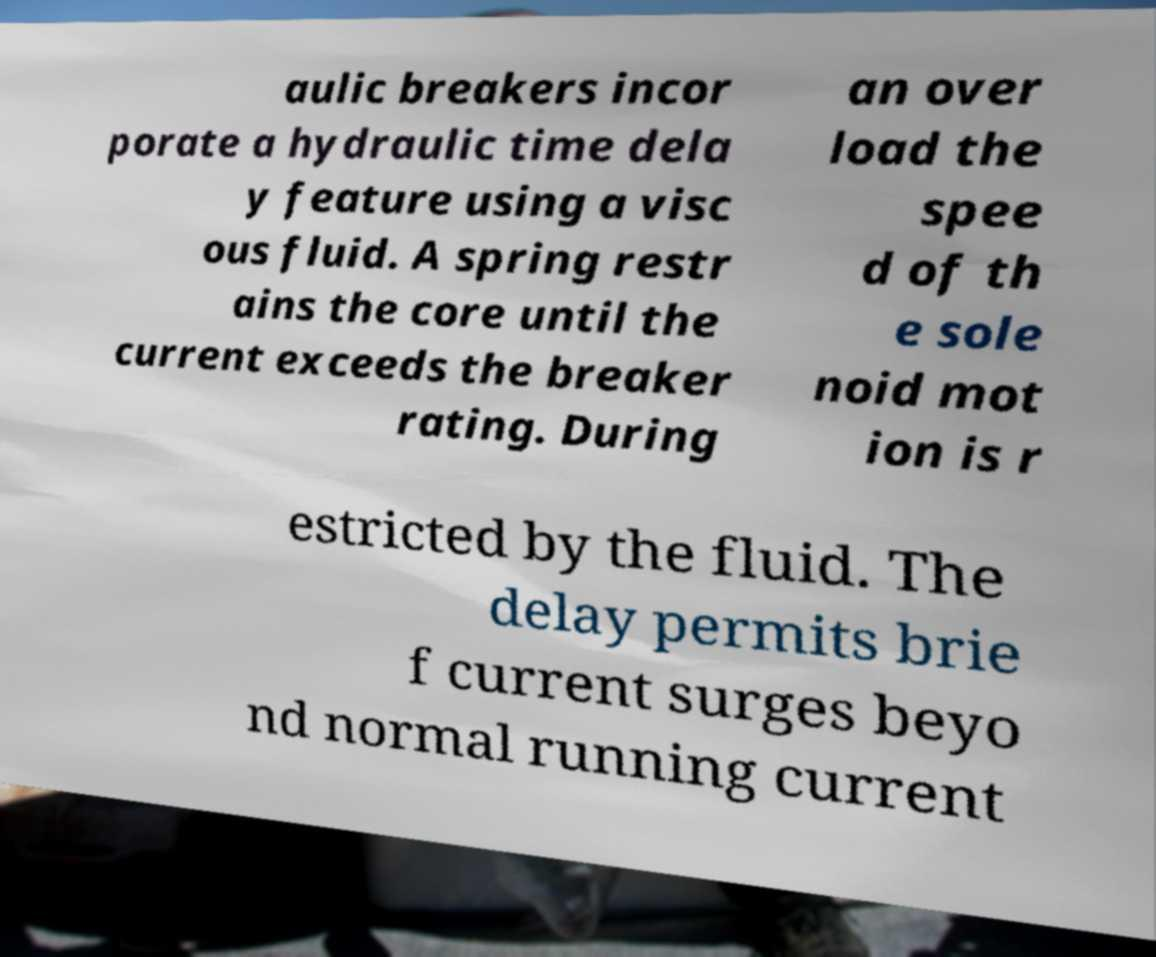Please read and relay the text visible in this image. What does it say? aulic breakers incor porate a hydraulic time dela y feature using a visc ous fluid. A spring restr ains the core until the current exceeds the breaker rating. During an over load the spee d of th e sole noid mot ion is r estricted by the fluid. The delay permits brie f current surges beyo nd normal running current 